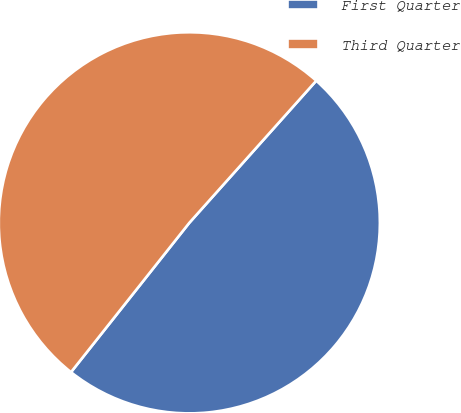<chart> <loc_0><loc_0><loc_500><loc_500><pie_chart><fcel>First Quarter<fcel>Third Quarter<nl><fcel>49.06%<fcel>50.94%<nl></chart> 